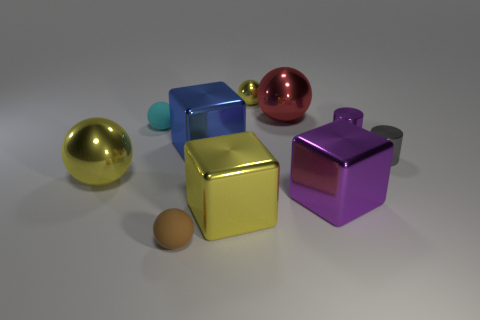What number of tiny things are either brown balls or purple matte balls?
Provide a succinct answer. 1. What color is the other matte sphere that is the same size as the cyan matte sphere?
Make the answer very short. Brown. There is a blue object; how many yellow cubes are behind it?
Keep it short and to the point. 0. Is there a brown thing made of the same material as the tiny cyan object?
Make the answer very short. Yes. What color is the large cube that is behind the large purple metal object?
Make the answer very short. Blue. Are there the same number of large yellow metallic objects that are in front of the large yellow cube and big purple cubes that are in front of the tiny metal sphere?
Your answer should be compact. No. What is the material of the brown ball that is on the right side of the yellow metal sphere that is in front of the cyan rubber object?
Keep it short and to the point. Rubber. How many things are small matte things or large cubes right of the tiny yellow sphere?
Provide a short and direct response. 3. What is the size of the purple block that is the same material as the yellow cube?
Ensure brevity in your answer.  Large. Is the number of spheres that are behind the blue shiny object greater than the number of large red matte cylinders?
Your answer should be very brief. Yes. 